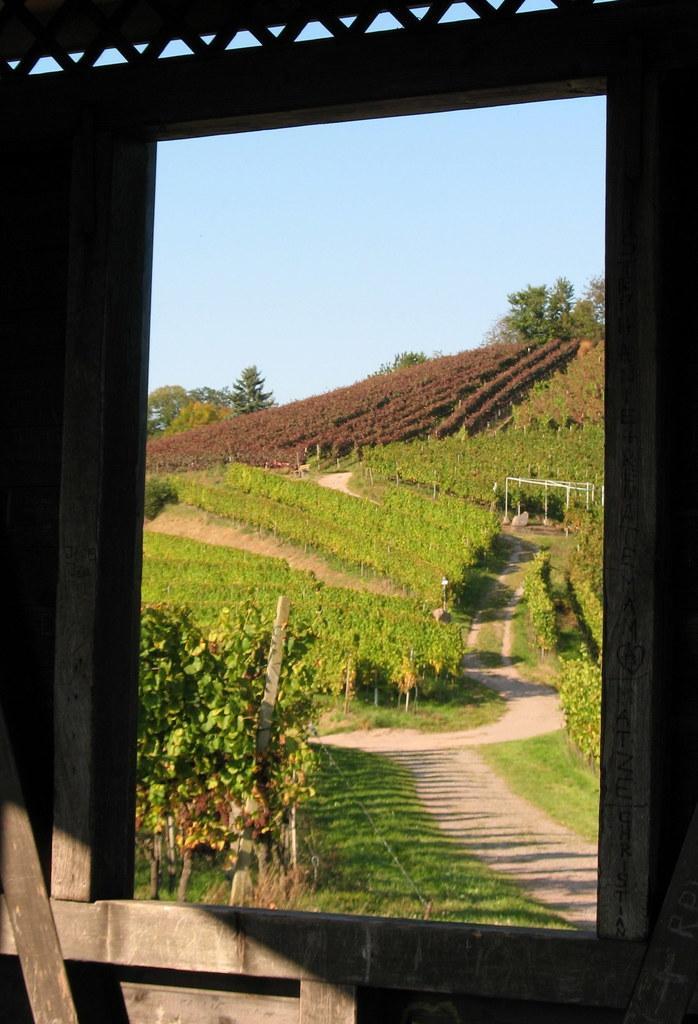Please provide a concise description of this image. In this image there is a wooden wall with a window through which we can see there are plants, trees and some structures. In the background there is a wall. 